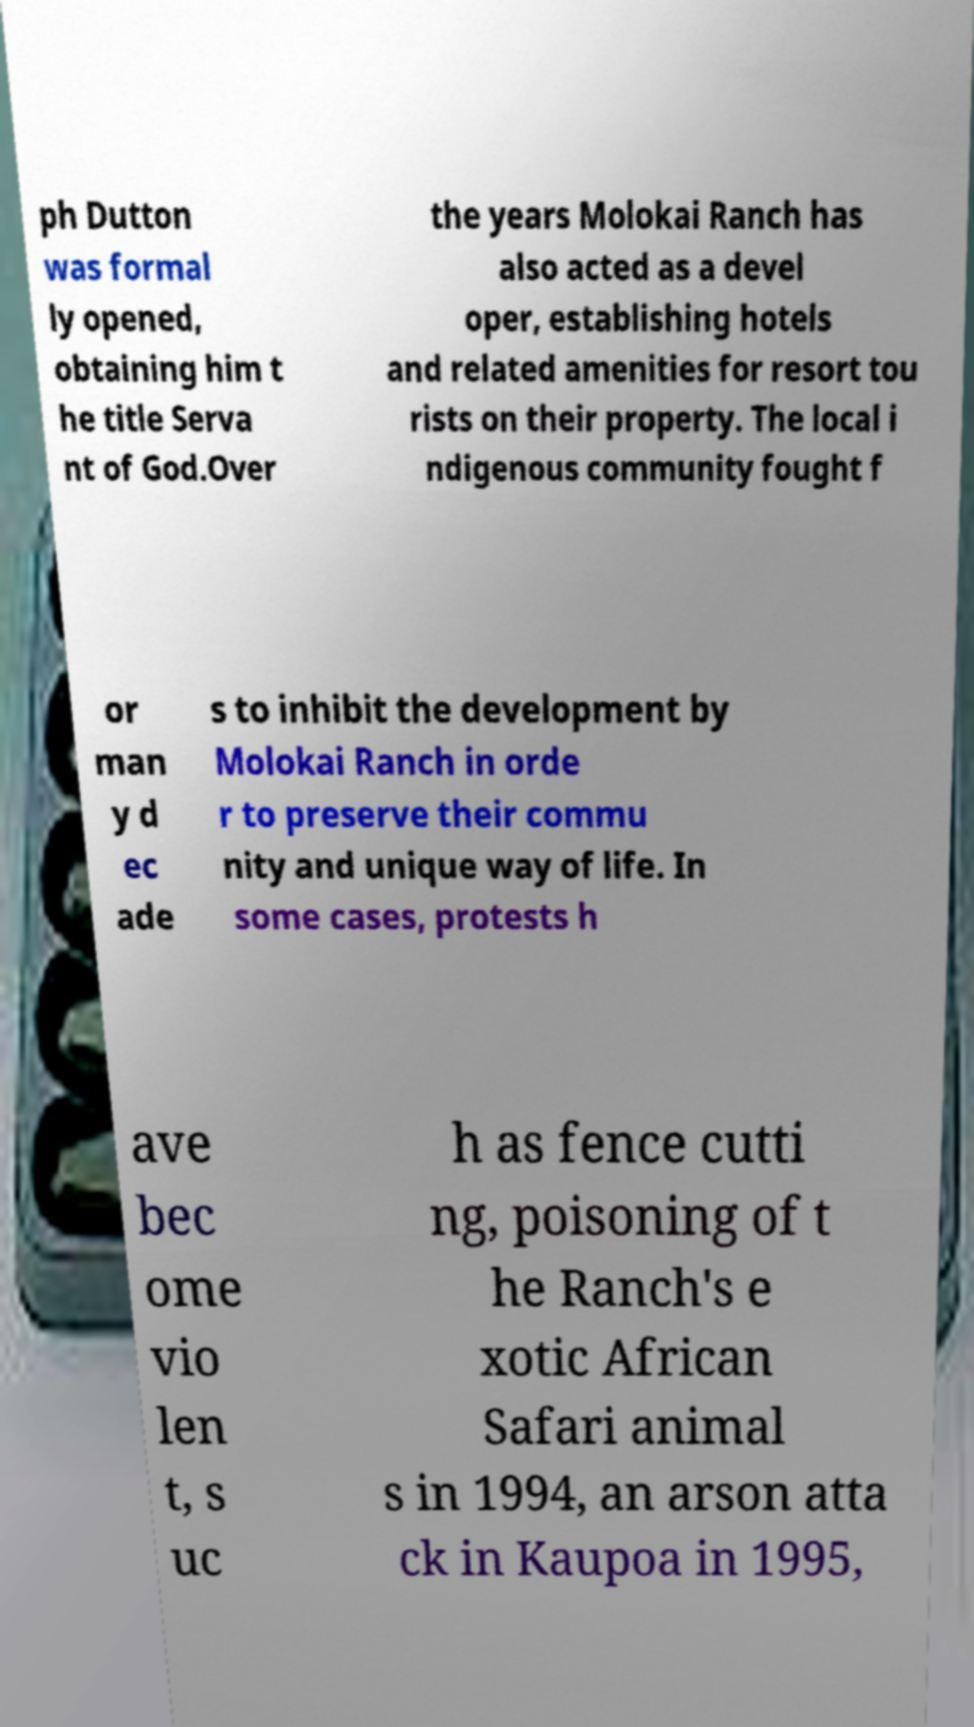I need the written content from this picture converted into text. Can you do that? ph Dutton was formal ly opened, obtaining him t he title Serva nt of God.Over the years Molokai Ranch has also acted as a devel oper, establishing hotels and related amenities for resort tou rists on their property. The local i ndigenous community fought f or man y d ec ade s to inhibit the development by Molokai Ranch in orde r to preserve their commu nity and unique way of life. In some cases, protests h ave bec ome vio len t, s uc h as fence cutti ng, poisoning of t he Ranch's e xotic African Safari animal s in 1994, an arson atta ck in Kaupoa in 1995, 